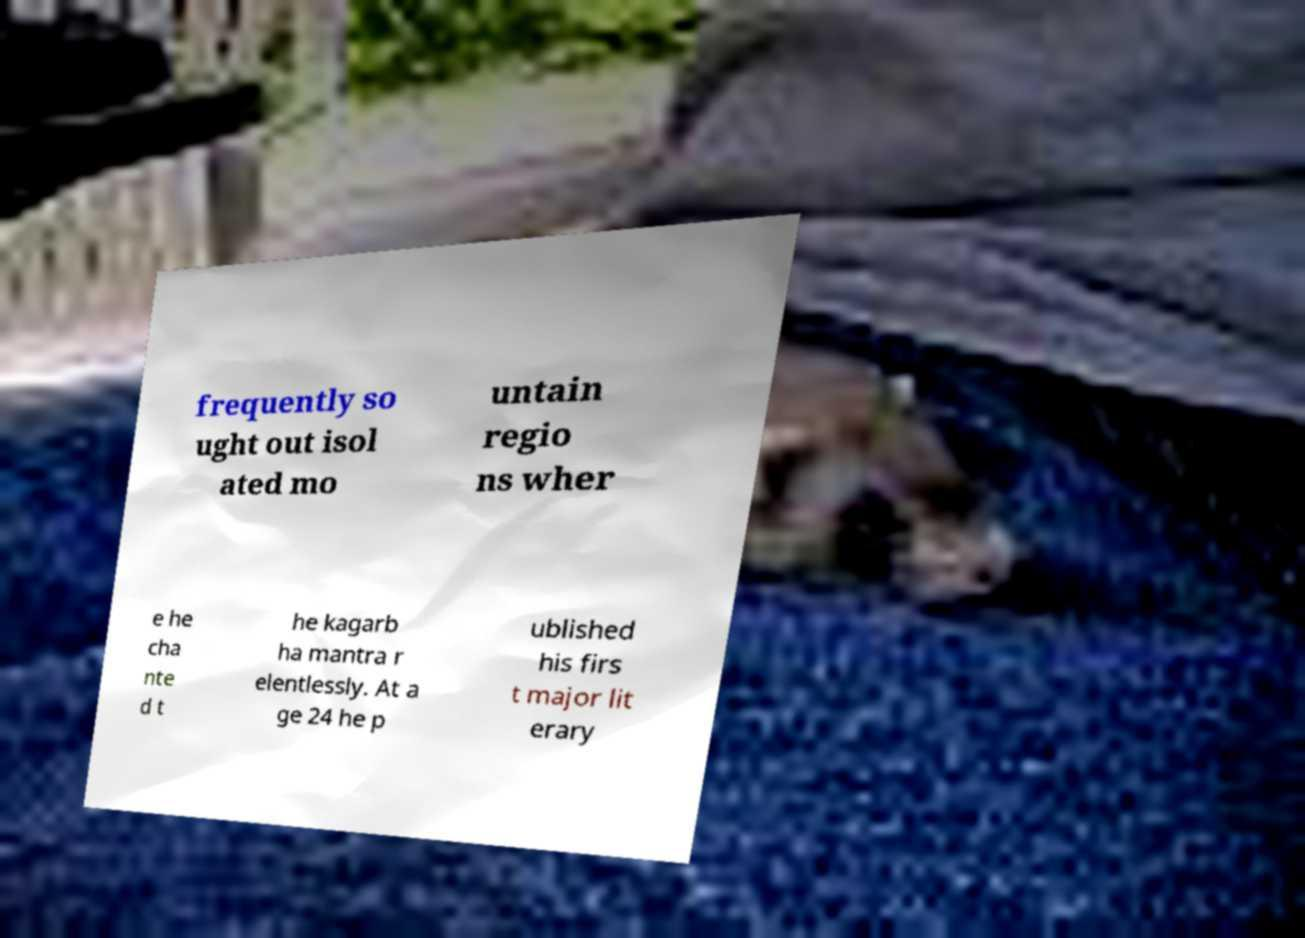Can you read and provide the text displayed in the image?This photo seems to have some interesting text. Can you extract and type it out for me? frequently so ught out isol ated mo untain regio ns wher e he cha nte d t he kagarb ha mantra r elentlessly. At a ge 24 he p ublished his firs t major lit erary 